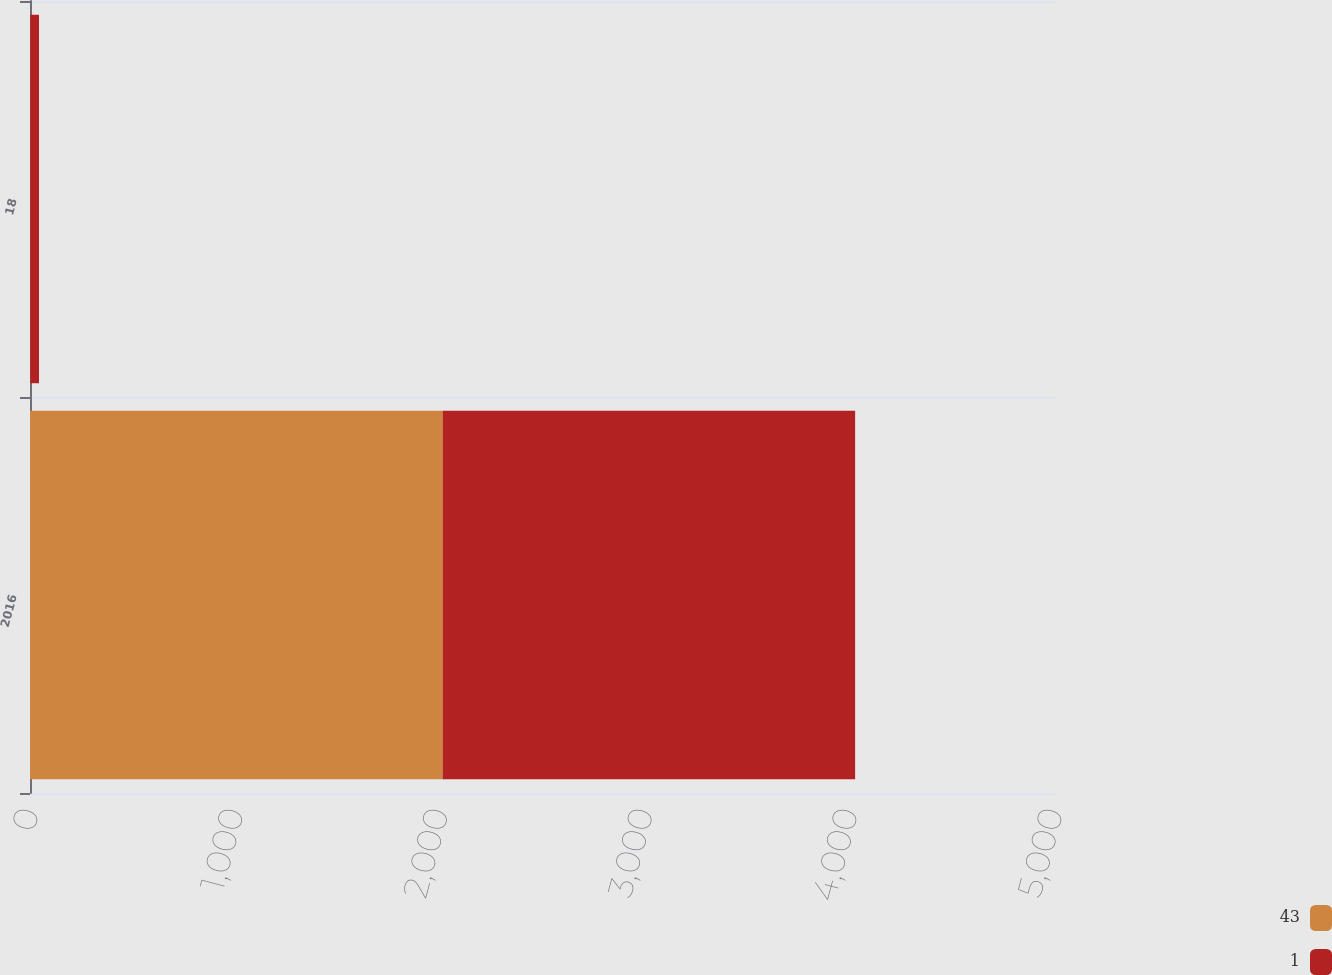Convert chart to OTSL. <chart><loc_0><loc_0><loc_500><loc_500><stacked_bar_chart><ecel><fcel>2016<fcel>18<nl><fcel>43<fcel>2015<fcel>1<nl><fcel>1<fcel>2014<fcel>43<nl></chart> 